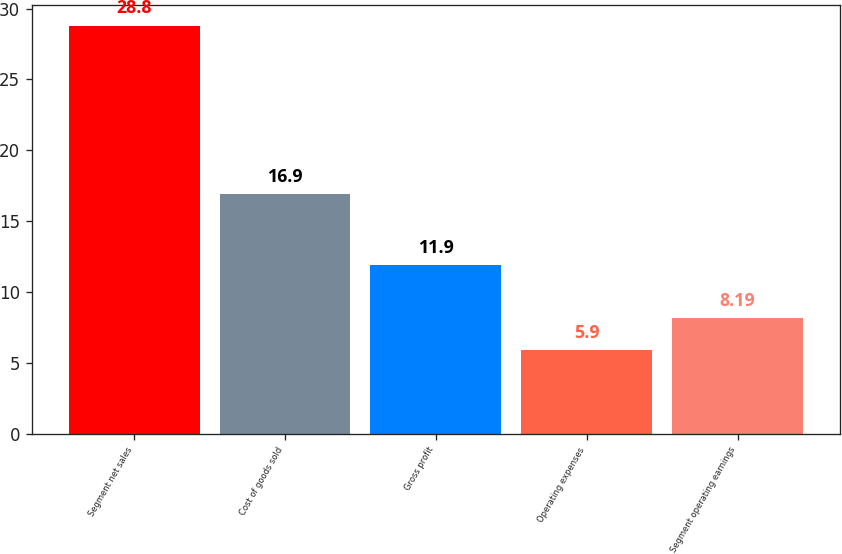Convert chart to OTSL. <chart><loc_0><loc_0><loc_500><loc_500><bar_chart><fcel>Segment net sales<fcel>Cost of goods sold<fcel>Gross profit<fcel>Operating expenses<fcel>Segment operating earnings<nl><fcel>28.8<fcel>16.9<fcel>11.9<fcel>5.9<fcel>8.19<nl></chart> 